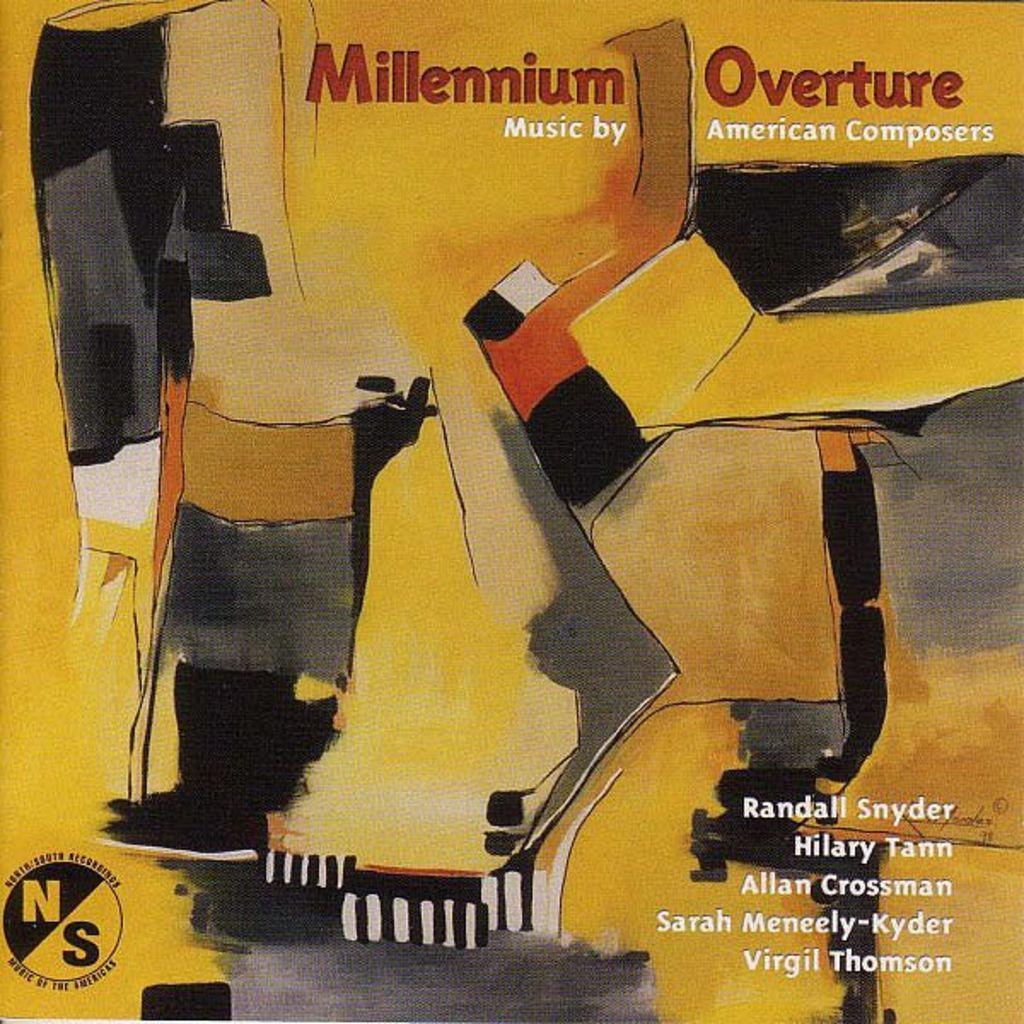<image>
Give a short and clear explanation of the subsequent image. An album cover titled Millennium Overture that includes different American composers. 